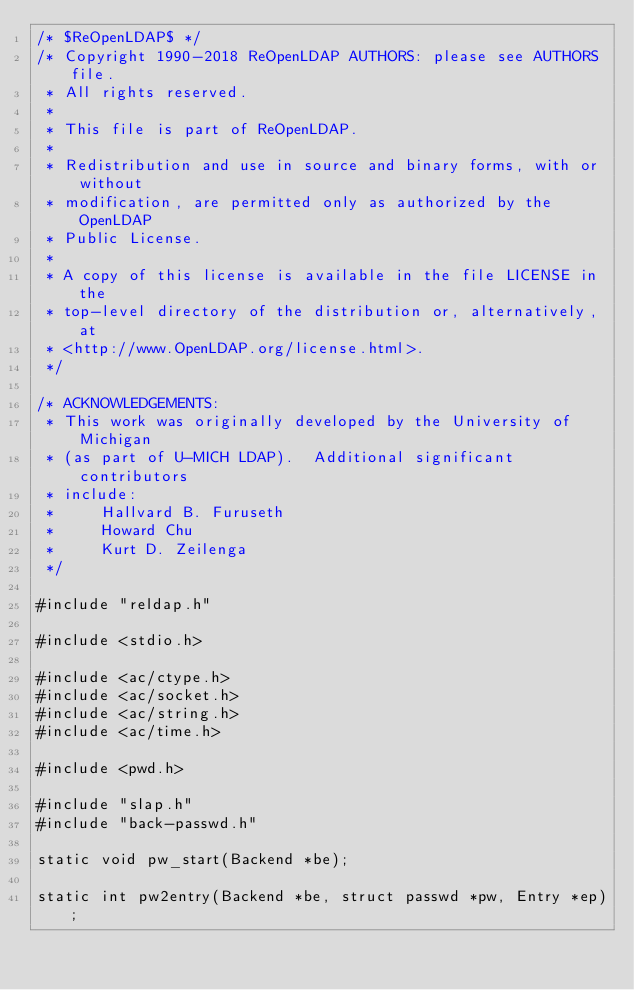Convert code to text. <code><loc_0><loc_0><loc_500><loc_500><_C_>/* $ReOpenLDAP$ */
/* Copyright 1990-2018 ReOpenLDAP AUTHORS: please see AUTHORS file.
 * All rights reserved.
 *
 * This file is part of ReOpenLDAP.
 *
 * Redistribution and use in source and binary forms, with or without
 * modification, are permitted only as authorized by the OpenLDAP
 * Public License.
 *
 * A copy of this license is available in the file LICENSE in the
 * top-level directory of the distribution or, alternatively, at
 * <http://www.OpenLDAP.org/license.html>.
 */

/* ACKNOWLEDGEMENTS:
 * This work was originally developed by the University of Michigan
 * (as part of U-MICH LDAP).  Additional significant contributors
 * include:
 *     Hallvard B. Furuseth
 *     Howard Chu
 *     Kurt D. Zeilenga
 */

#include "reldap.h"

#include <stdio.h>

#include <ac/ctype.h>
#include <ac/socket.h>
#include <ac/string.h>
#include <ac/time.h>

#include <pwd.h>

#include "slap.h"
#include "back-passwd.h"

static void pw_start(Backend *be);

static int pw2entry(Backend *be, struct passwd *pw, Entry *ep);
</code> 